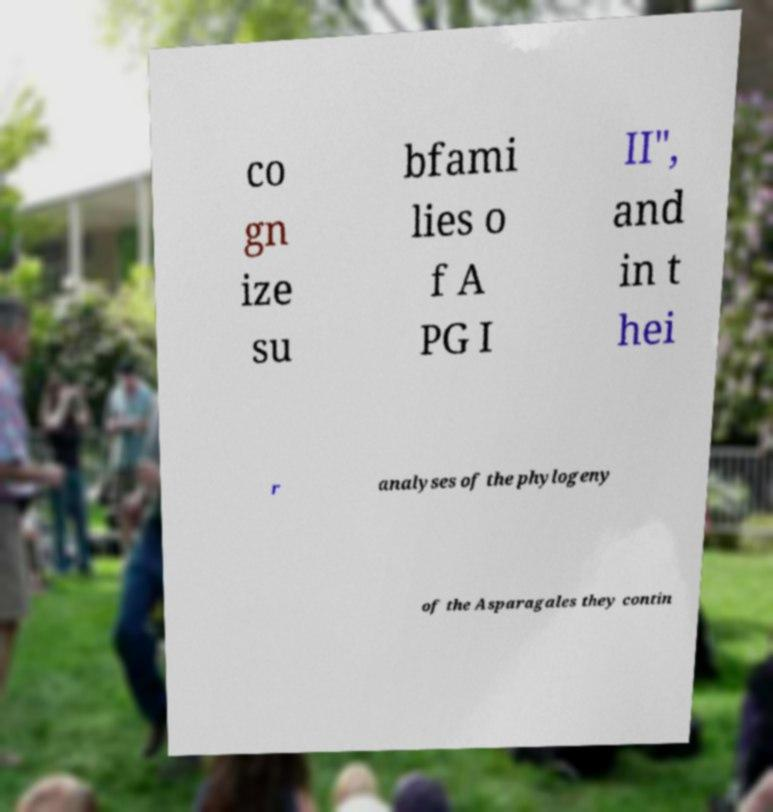Can you accurately transcribe the text from the provided image for me? co gn ize su bfami lies o f A PG I II", and in t hei r analyses of the phylogeny of the Asparagales they contin 